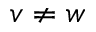Convert formula to latex. <formula><loc_0><loc_0><loc_500><loc_500>v \neq w</formula> 